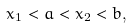Convert formula to latex. <formula><loc_0><loc_0><loc_500><loc_500>x _ { 1 } < a < x _ { 2 } < b ,</formula> 